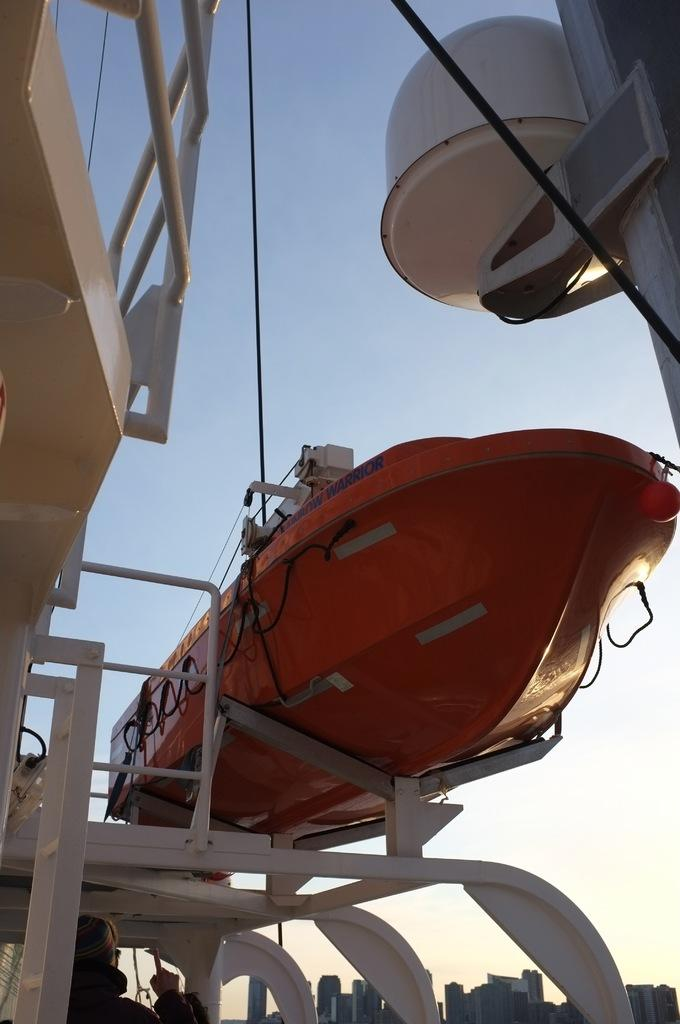What is the main subject of the image? The main subject of the image is a boat. Can you describe the boat's position in the image? The boat appears to be in the air. Are there any people visible in the image? Yes, there are people visible at the bottom of the image. What type of cub can be seen playing with a zoo in the image? There is no cub or zoo present in the image. Can you tell me which person's nose is the longest in the image? There is no information about the length of anyone's nose in the image. 